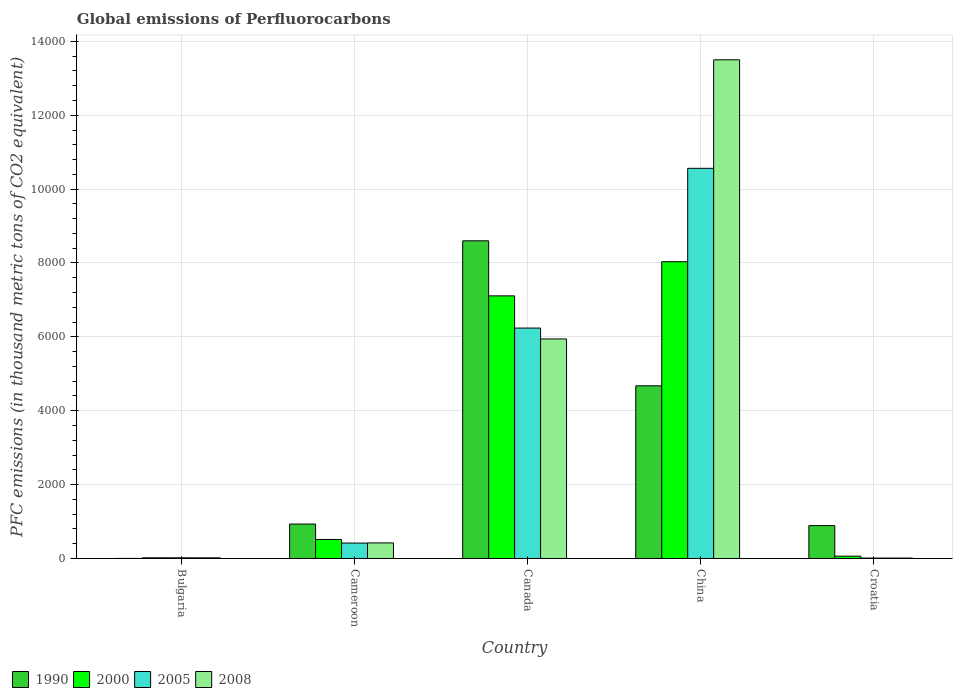How many different coloured bars are there?
Keep it short and to the point. 4. Are the number of bars per tick equal to the number of legend labels?
Your answer should be very brief. Yes. How many bars are there on the 1st tick from the left?
Make the answer very short. 4. How many bars are there on the 1st tick from the right?
Provide a short and direct response. 4. What is the label of the 1st group of bars from the left?
Offer a very short reply. Bulgaria. In how many cases, is the number of bars for a given country not equal to the number of legend labels?
Provide a short and direct response. 0. What is the global emissions of Perfluorocarbons in 1990 in Canada?
Make the answer very short. 8600.3. Across all countries, what is the maximum global emissions of Perfluorocarbons in 2000?
Your answer should be very brief. 8034.4. Across all countries, what is the minimum global emissions of Perfluorocarbons in 2008?
Give a very brief answer. 11. In which country was the global emissions of Perfluorocarbons in 1990 maximum?
Offer a very short reply. Canada. In which country was the global emissions of Perfluorocarbons in 2000 minimum?
Offer a terse response. Bulgaria. What is the total global emissions of Perfluorocarbons in 2000 in the graph?
Offer a terse response. 1.57e+04. What is the difference between the global emissions of Perfluorocarbons in 2008 in Bulgaria and that in Canada?
Your response must be concise. -5925.5. What is the difference between the global emissions of Perfluorocarbons in 2000 in Croatia and the global emissions of Perfluorocarbons in 2008 in Bulgaria?
Ensure brevity in your answer.  44.8. What is the average global emissions of Perfluorocarbons in 2005 per country?
Your answer should be compact. 3449.54. What is the difference between the global emissions of Perfluorocarbons of/in 1990 and global emissions of Perfluorocarbons of/in 2000 in Cameroon?
Keep it short and to the point. 417.6. In how many countries, is the global emissions of Perfluorocarbons in 2005 greater than 12800 thousand metric tons?
Your answer should be very brief. 0. What is the ratio of the global emissions of Perfluorocarbons in 2000 in Cameroon to that in Croatia?
Provide a short and direct response. 8.17. Is the global emissions of Perfluorocarbons in 2008 in Bulgaria less than that in Cameroon?
Keep it short and to the point. Yes. What is the difference between the highest and the second highest global emissions of Perfluorocarbons in 1990?
Keep it short and to the point. 3925.8. What is the difference between the highest and the lowest global emissions of Perfluorocarbons in 2000?
Your answer should be very brief. 8015.3. In how many countries, is the global emissions of Perfluorocarbons in 2005 greater than the average global emissions of Perfluorocarbons in 2005 taken over all countries?
Keep it short and to the point. 2. Is the sum of the global emissions of Perfluorocarbons in 1990 in Cameroon and Croatia greater than the maximum global emissions of Perfluorocarbons in 2008 across all countries?
Provide a short and direct response. No. Is it the case that in every country, the sum of the global emissions of Perfluorocarbons in 2005 and global emissions of Perfluorocarbons in 1990 is greater than the global emissions of Perfluorocarbons in 2008?
Make the answer very short. Yes. What is the difference between two consecutive major ticks on the Y-axis?
Keep it short and to the point. 2000. Are the values on the major ticks of Y-axis written in scientific E-notation?
Provide a succinct answer. No. Does the graph contain any zero values?
Ensure brevity in your answer.  No. How are the legend labels stacked?
Keep it short and to the point. Horizontal. What is the title of the graph?
Offer a terse response. Global emissions of Perfluorocarbons. Does "1979" appear as one of the legend labels in the graph?
Give a very brief answer. No. What is the label or title of the X-axis?
Provide a short and direct response. Country. What is the label or title of the Y-axis?
Give a very brief answer. PFC emissions (in thousand metric tons of CO2 equivalent). What is the PFC emissions (in thousand metric tons of CO2 equivalent) in 2000 in Bulgaria?
Provide a succinct answer. 19.1. What is the PFC emissions (in thousand metric tons of CO2 equivalent) of 2005 in Bulgaria?
Ensure brevity in your answer.  18.5. What is the PFC emissions (in thousand metric tons of CO2 equivalent) in 2008 in Bulgaria?
Give a very brief answer. 18.2. What is the PFC emissions (in thousand metric tons of CO2 equivalent) of 1990 in Cameroon?
Ensure brevity in your answer.  932.3. What is the PFC emissions (in thousand metric tons of CO2 equivalent) of 2000 in Cameroon?
Offer a very short reply. 514.7. What is the PFC emissions (in thousand metric tons of CO2 equivalent) in 2005 in Cameroon?
Keep it short and to the point. 417.5. What is the PFC emissions (in thousand metric tons of CO2 equivalent) in 2008 in Cameroon?
Your answer should be very brief. 422.1. What is the PFC emissions (in thousand metric tons of CO2 equivalent) in 1990 in Canada?
Provide a succinct answer. 8600.3. What is the PFC emissions (in thousand metric tons of CO2 equivalent) in 2000 in Canada?
Your answer should be very brief. 7109.9. What is the PFC emissions (in thousand metric tons of CO2 equivalent) of 2005 in Canada?
Offer a terse response. 6238. What is the PFC emissions (in thousand metric tons of CO2 equivalent) in 2008 in Canada?
Make the answer very short. 5943.7. What is the PFC emissions (in thousand metric tons of CO2 equivalent) of 1990 in China?
Provide a short and direct response. 4674.5. What is the PFC emissions (in thousand metric tons of CO2 equivalent) of 2000 in China?
Make the answer very short. 8034.4. What is the PFC emissions (in thousand metric tons of CO2 equivalent) of 2005 in China?
Offer a terse response. 1.06e+04. What is the PFC emissions (in thousand metric tons of CO2 equivalent) of 2008 in China?
Ensure brevity in your answer.  1.35e+04. What is the PFC emissions (in thousand metric tons of CO2 equivalent) in 1990 in Croatia?
Keep it short and to the point. 890.4. What is the PFC emissions (in thousand metric tons of CO2 equivalent) of 2005 in Croatia?
Provide a succinct answer. 10.9. Across all countries, what is the maximum PFC emissions (in thousand metric tons of CO2 equivalent) in 1990?
Give a very brief answer. 8600.3. Across all countries, what is the maximum PFC emissions (in thousand metric tons of CO2 equivalent) of 2000?
Your answer should be very brief. 8034.4. Across all countries, what is the maximum PFC emissions (in thousand metric tons of CO2 equivalent) of 2005?
Your response must be concise. 1.06e+04. Across all countries, what is the maximum PFC emissions (in thousand metric tons of CO2 equivalent) in 2008?
Offer a very short reply. 1.35e+04. Across all countries, what is the minimum PFC emissions (in thousand metric tons of CO2 equivalent) in 1990?
Your answer should be compact. 2.2. Across all countries, what is the minimum PFC emissions (in thousand metric tons of CO2 equivalent) in 2005?
Give a very brief answer. 10.9. Across all countries, what is the minimum PFC emissions (in thousand metric tons of CO2 equivalent) in 2008?
Your response must be concise. 11. What is the total PFC emissions (in thousand metric tons of CO2 equivalent) of 1990 in the graph?
Make the answer very short. 1.51e+04. What is the total PFC emissions (in thousand metric tons of CO2 equivalent) in 2000 in the graph?
Provide a succinct answer. 1.57e+04. What is the total PFC emissions (in thousand metric tons of CO2 equivalent) in 2005 in the graph?
Give a very brief answer. 1.72e+04. What is the total PFC emissions (in thousand metric tons of CO2 equivalent) in 2008 in the graph?
Make the answer very short. 1.99e+04. What is the difference between the PFC emissions (in thousand metric tons of CO2 equivalent) of 1990 in Bulgaria and that in Cameroon?
Give a very brief answer. -930.1. What is the difference between the PFC emissions (in thousand metric tons of CO2 equivalent) in 2000 in Bulgaria and that in Cameroon?
Keep it short and to the point. -495.6. What is the difference between the PFC emissions (in thousand metric tons of CO2 equivalent) of 2005 in Bulgaria and that in Cameroon?
Your answer should be very brief. -399. What is the difference between the PFC emissions (in thousand metric tons of CO2 equivalent) in 2008 in Bulgaria and that in Cameroon?
Your answer should be very brief. -403.9. What is the difference between the PFC emissions (in thousand metric tons of CO2 equivalent) in 1990 in Bulgaria and that in Canada?
Ensure brevity in your answer.  -8598.1. What is the difference between the PFC emissions (in thousand metric tons of CO2 equivalent) in 2000 in Bulgaria and that in Canada?
Offer a very short reply. -7090.8. What is the difference between the PFC emissions (in thousand metric tons of CO2 equivalent) in 2005 in Bulgaria and that in Canada?
Your answer should be compact. -6219.5. What is the difference between the PFC emissions (in thousand metric tons of CO2 equivalent) of 2008 in Bulgaria and that in Canada?
Provide a succinct answer. -5925.5. What is the difference between the PFC emissions (in thousand metric tons of CO2 equivalent) in 1990 in Bulgaria and that in China?
Your answer should be compact. -4672.3. What is the difference between the PFC emissions (in thousand metric tons of CO2 equivalent) in 2000 in Bulgaria and that in China?
Offer a very short reply. -8015.3. What is the difference between the PFC emissions (in thousand metric tons of CO2 equivalent) in 2005 in Bulgaria and that in China?
Give a very brief answer. -1.05e+04. What is the difference between the PFC emissions (in thousand metric tons of CO2 equivalent) in 2008 in Bulgaria and that in China?
Keep it short and to the point. -1.35e+04. What is the difference between the PFC emissions (in thousand metric tons of CO2 equivalent) of 1990 in Bulgaria and that in Croatia?
Offer a terse response. -888.2. What is the difference between the PFC emissions (in thousand metric tons of CO2 equivalent) of 2000 in Bulgaria and that in Croatia?
Ensure brevity in your answer.  -43.9. What is the difference between the PFC emissions (in thousand metric tons of CO2 equivalent) in 2005 in Bulgaria and that in Croatia?
Keep it short and to the point. 7.6. What is the difference between the PFC emissions (in thousand metric tons of CO2 equivalent) of 1990 in Cameroon and that in Canada?
Your answer should be very brief. -7668. What is the difference between the PFC emissions (in thousand metric tons of CO2 equivalent) in 2000 in Cameroon and that in Canada?
Offer a very short reply. -6595.2. What is the difference between the PFC emissions (in thousand metric tons of CO2 equivalent) of 2005 in Cameroon and that in Canada?
Offer a very short reply. -5820.5. What is the difference between the PFC emissions (in thousand metric tons of CO2 equivalent) in 2008 in Cameroon and that in Canada?
Keep it short and to the point. -5521.6. What is the difference between the PFC emissions (in thousand metric tons of CO2 equivalent) in 1990 in Cameroon and that in China?
Keep it short and to the point. -3742.2. What is the difference between the PFC emissions (in thousand metric tons of CO2 equivalent) in 2000 in Cameroon and that in China?
Provide a succinct answer. -7519.7. What is the difference between the PFC emissions (in thousand metric tons of CO2 equivalent) in 2005 in Cameroon and that in China?
Provide a succinct answer. -1.01e+04. What is the difference between the PFC emissions (in thousand metric tons of CO2 equivalent) in 2008 in Cameroon and that in China?
Make the answer very short. -1.31e+04. What is the difference between the PFC emissions (in thousand metric tons of CO2 equivalent) of 1990 in Cameroon and that in Croatia?
Make the answer very short. 41.9. What is the difference between the PFC emissions (in thousand metric tons of CO2 equivalent) in 2000 in Cameroon and that in Croatia?
Keep it short and to the point. 451.7. What is the difference between the PFC emissions (in thousand metric tons of CO2 equivalent) in 2005 in Cameroon and that in Croatia?
Your answer should be compact. 406.6. What is the difference between the PFC emissions (in thousand metric tons of CO2 equivalent) of 2008 in Cameroon and that in Croatia?
Provide a short and direct response. 411.1. What is the difference between the PFC emissions (in thousand metric tons of CO2 equivalent) in 1990 in Canada and that in China?
Ensure brevity in your answer.  3925.8. What is the difference between the PFC emissions (in thousand metric tons of CO2 equivalent) in 2000 in Canada and that in China?
Offer a terse response. -924.5. What is the difference between the PFC emissions (in thousand metric tons of CO2 equivalent) in 2005 in Canada and that in China?
Your answer should be compact. -4324.8. What is the difference between the PFC emissions (in thousand metric tons of CO2 equivalent) in 2008 in Canada and that in China?
Provide a succinct answer. -7556.9. What is the difference between the PFC emissions (in thousand metric tons of CO2 equivalent) of 1990 in Canada and that in Croatia?
Give a very brief answer. 7709.9. What is the difference between the PFC emissions (in thousand metric tons of CO2 equivalent) of 2000 in Canada and that in Croatia?
Keep it short and to the point. 7046.9. What is the difference between the PFC emissions (in thousand metric tons of CO2 equivalent) of 2005 in Canada and that in Croatia?
Make the answer very short. 6227.1. What is the difference between the PFC emissions (in thousand metric tons of CO2 equivalent) in 2008 in Canada and that in Croatia?
Make the answer very short. 5932.7. What is the difference between the PFC emissions (in thousand metric tons of CO2 equivalent) in 1990 in China and that in Croatia?
Provide a short and direct response. 3784.1. What is the difference between the PFC emissions (in thousand metric tons of CO2 equivalent) of 2000 in China and that in Croatia?
Provide a short and direct response. 7971.4. What is the difference between the PFC emissions (in thousand metric tons of CO2 equivalent) in 2005 in China and that in Croatia?
Offer a terse response. 1.06e+04. What is the difference between the PFC emissions (in thousand metric tons of CO2 equivalent) of 2008 in China and that in Croatia?
Provide a succinct answer. 1.35e+04. What is the difference between the PFC emissions (in thousand metric tons of CO2 equivalent) in 1990 in Bulgaria and the PFC emissions (in thousand metric tons of CO2 equivalent) in 2000 in Cameroon?
Your answer should be very brief. -512.5. What is the difference between the PFC emissions (in thousand metric tons of CO2 equivalent) of 1990 in Bulgaria and the PFC emissions (in thousand metric tons of CO2 equivalent) of 2005 in Cameroon?
Your answer should be compact. -415.3. What is the difference between the PFC emissions (in thousand metric tons of CO2 equivalent) of 1990 in Bulgaria and the PFC emissions (in thousand metric tons of CO2 equivalent) of 2008 in Cameroon?
Make the answer very short. -419.9. What is the difference between the PFC emissions (in thousand metric tons of CO2 equivalent) of 2000 in Bulgaria and the PFC emissions (in thousand metric tons of CO2 equivalent) of 2005 in Cameroon?
Provide a succinct answer. -398.4. What is the difference between the PFC emissions (in thousand metric tons of CO2 equivalent) of 2000 in Bulgaria and the PFC emissions (in thousand metric tons of CO2 equivalent) of 2008 in Cameroon?
Offer a terse response. -403. What is the difference between the PFC emissions (in thousand metric tons of CO2 equivalent) in 2005 in Bulgaria and the PFC emissions (in thousand metric tons of CO2 equivalent) in 2008 in Cameroon?
Ensure brevity in your answer.  -403.6. What is the difference between the PFC emissions (in thousand metric tons of CO2 equivalent) of 1990 in Bulgaria and the PFC emissions (in thousand metric tons of CO2 equivalent) of 2000 in Canada?
Offer a terse response. -7107.7. What is the difference between the PFC emissions (in thousand metric tons of CO2 equivalent) in 1990 in Bulgaria and the PFC emissions (in thousand metric tons of CO2 equivalent) in 2005 in Canada?
Ensure brevity in your answer.  -6235.8. What is the difference between the PFC emissions (in thousand metric tons of CO2 equivalent) in 1990 in Bulgaria and the PFC emissions (in thousand metric tons of CO2 equivalent) in 2008 in Canada?
Provide a short and direct response. -5941.5. What is the difference between the PFC emissions (in thousand metric tons of CO2 equivalent) of 2000 in Bulgaria and the PFC emissions (in thousand metric tons of CO2 equivalent) of 2005 in Canada?
Provide a succinct answer. -6218.9. What is the difference between the PFC emissions (in thousand metric tons of CO2 equivalent) in 2000 in Bulgaria and the PFC emissions (in thousand metric tons of CO2 equivalent) in 2008 in Canada?
Ensure brevity in your answer.  -5924.6. What is the difference between the PFC emissions (in thousand metric tons of CO2 equivalent) in 2005 in Bulgaria and the PFC emissions (in thousand metric tons of CO2 equivalent) in 2008 in Canada?
Offer a terse response. -5925.2. What is the difference between the PFC emissions (in thousand metric tons of CO2 equivalent) in 1990 in Bulgaria and the PFC emissions (in thousand metric tons of CO2 equivalent) in 2000 in China?
Make the answer very short. -8032.2. What is the difference between the PFC emissions (in thousand metric tons of CO2 equivalent) in 1990 in Bulgaria and the PFC emissions (in thousand metric tons of CO2 equivalent) in 2005 in China?
Your response must be concise. -1.06e+04. What is the difference between the PFC emissions (in thousand metric tons of CO2 equivalent) in 1990 in Bulgaria and the PFC emissions (in thousand metric tons of CO2 equivalent) in 2008 in China?
Offer a very short reply. -1.35e+04. What is the difference between the PFC emissions (in thousand metric tons of CO2 equivalent) of 2000 in Bulgaria and the PFC emissions (in thousand metric tons of CO2 equivalent) of 2005 in China?
Provide a short and direct response. -1.05e+04. What is the difference between the PFC emissions (in thousand metric tons of CO2 equivalent) of 2000 in Bulgaria and the PFC emissions (in thousand metric tons of CO2 equivalent) of 2008 in China?
Provide a succinct answer. -1.35e+04. What is the difference between the PFC emissions (in thousand metric tons of CO2 equivalent) of 2005 in Bulgaria and the PFC emissions (in thousand metric tons of CO2 equivalent) of 2008 in China?
Provide a succinct answer. -1.35e+04. What is the difference between the PFC emissions (in thousand metric tons of CO2 equivalent) of 1990 in Bulgaria and the PFC emissions (in thousand metric tons of CO2 equivalent) of 2000 in Croatia?
Keep it short and to the point. -60.8. What is the difference between the PFC emissions (in thousand metric tons of CO2 equivalent) of 1990 in Bulgaria and the PFC emissions (in thousand metric tons of CO2 equivalent) of 2005 in Croatia?
Keep it short and to the point. -8.7. What is the difference between the PFC emissions (in thousand metric tons of CO2 equivalent) in 1990 in Bulgaria and the PFC emissions (in thousand metric tons of CO2 equivalent) in 2008 in Croatia?
Your answer should be very brief. -8.8. What is the difference between the PFC emissions (in thousand metric tons of CO2 equivalent) of 2000 in Bulgaria and the PFC emissions (in thousand metric tons of CO2 equivalent) of 2005 in Croatia?
Provide a short and direct response. 8.2. What is the difference between the PFC emissions (in thousand metric tons of CO2 equivalent) in 2005 in Bulgaria and the PFC emissions (in thousand metric tons of CO2 equivalent) in 2008 in Croatia?
Give a very brief answer. 7.5. What is the difference between the PFC emissions (in thousand metric tons of CO2 equivalent) of 1990 in Cameroon and the PFC emissions (in thousand metric tons of CO2 equivalent) of 2000 in Canada?
Provide a succinct answer. -6177.6. What is the difference between the PFC emissions (in thousand metric tons of CO2 equivalent) in 1990 in Cameroon and the PFC emissions (in thousand metric tons of CO2 equivalent) in 2005 in Canada?
Keep it short and to the point. -5305.7. What is the difference between the PFC emissions (in thousand metric tons of CO2 equivalent) of 1990 in Cameroon and the PFC emissions (in thousand metric tons of CO2 equivalent) of 2008 in Canada?
Offer a very short reply. -5011.4. What is the difference between the PFC emissions (in thousand metric tons of CO2 equivalent) in 2000 in Cameroon and the PFC emissions (in thousand metric tons of CO2 equivalent) in 2005 in Canada?
Your answer should be very brief. -5723.3. What is the difference between the PFC emissions (in thousand metric tons of CO2 equivalent) in 2000 in Cameroon and the PFC emissions (in thousand metric tons of CO2 equivalent) in 2008 in Canada?
Provide a succinct answer. -5429. What is the difference between the PFC emissions (in thousand metric tons of CO2 equivalent) of 2005 in Cameroon and the PFC emissions (in thousand metric tons of CO2 equivalent) of 2008 in Canada?
Offer a very short reply. -5526.2. What is the difference between the PFC emissions (in thousand metric tons of CO2 equivalent) of 1990 in Cameroon and the PFC emissions (in thousand metric tons of CO2 equivalent) of 2000 in China?
Your answer should be very brief. -7102.1. What is the difference between the PFC emissions (in thousand metric tons of CO2 equivalent) in 1990 in Cameroon and the PFC emissions (in thousand metric tons of CO2 equivalent) in 2005 in China?
Provide a succinct answer. -9630.5. What is the difference between the PFC emissions (in thousand metric tons of CO2 equivalent) in 1990 in Cameroon and the PFC emissions (in thousand metric tons of CO2 equivalent) in 2008 in China?
Ensure brevity in your answer.  -1.26e+04. What is the difference between the PFC emissions (in thousand metric tons of CO2 equivalent) in 2000 in Cameroon and the PFC emissions (in thousand metric tons of CO2 equivalent) in 2005 in China?
Offer a terse response. -1.00e+04. What is the difference between the PFC emissions (in thousand metric tons of CO2 equivalent) in 2000 in Cameroon and the PFC emissions (in thousand metric tons of CO2 equivalent) in 2008 in China?
Offer a very short reply. -1.30e+04. What is the difference between the PFC emissions (in thousand metric tons of CO2 equivalent) in 2005 in Cameroon and the PFC emissions (in thousand metric tons of CO2 equivalent) in 2008 in China?
Offer a terse response. -1.31e+04. What is the difference between the PFC emissions (in thousand metric tons of CO2 equivalent) of 1990 in Cameroon and the PFC emissions (in thousand metric tons of CO2 equivalent) of 2000 in Croatia?
Ensure brevity in your answer.  869.3. What is the difference between the PFC emissions (in thousand metric tons of CO2 equivalent) of 1990 in Cameroon and the PFC emissions (in thousand metric tons of CO2 equivalent) of 2005 in Croatia?
Your response must be concise. 921.4. What is the difference between the PFC emissions (in thousand metric tons of CO2 equivalent) in 1990 in Cameroon and the PFC emissions (in thousand metric tons of CO2 equivalent) in 2008 in Croatia?
Your answer should be compact. 921.3. What is the difference between the PFC emissions (in thousand metric tons of CO2 equivalent) in 2000 in Cameroon and the PFC emissions (in thousand metric tons of CO2 equivalent) in 2005 in Croatia?
Your response must be concise. 503.8. What is the difference between the PFC emissions (in thousand metric tons of CO2 equivalent) of 2000 in Cameroon and the PFC emissions (in thousand metric tons of CO2 equivalent) of 2008 in Croatia?
Provide a succinct answer. 503.7. What is the difference between the PFC emissions (in thousand metric tons of CO2 equivalent) in 2005 in Cameroon and the PFC emissions (in thousand metric tons of CO2 equivalent) in 2008 in Croatia?
Ensure brevity in your answer.  406.5. What is the difference between the PFC emissions (in thousand metric tons of CO2 equivalent) of 1990 in Canada and the PFC emissions (in thousand metric tons of CO2 equivalent) of 2000 in China?
Offer a very short reply. 565.9. What is the difference between the PFC emissions (in thousand metric tons of CO2 equivalent) of 1990 in Canada and the PFC emissions (in thousand metric tons of CO2 equivalent) of 2005 in China?
Offer a very short reply. -1962.5. What is the difference between the PFC emissions (in thousand metric tons of CO2 equivalent) of 1990 in Canada and the PFC emissions (in thousand metric tons of CO2 equivalent) of 2008 in China?
Your answer should be very brief. -4900.3. What is the difference between the PFC emissions (in thousand metric tons of CO2 equivalent) in 2000 in Canada and the PFC emissions (in thousand metric tons of CO2 equivalent) in 2005 in China?
Make the answer very short. -3452.9. What is the difference between the PFC emissions (in thousand metric tons of CO2 equivalent) of 2000 in Canada and the PFC emissions (in thousand metric tons of CO2 equivalent) of 2008 in China?
Give a very brief answer. -6390.7. What is the difference between the PFC emissions (in thousand metric tons of CO2 equivalent) in 2005 in Canada and the PFC emissions (in thousand metric tons of CO2 equivalent) in 2008 in China?
Your answer should be compact. -7262.6. What is the difference between the PFC emissions (in thousand metric tons of CO2 equivalent) of 1990 in Canada and the PFC emissions (in thousand metric tons of CO2 equivalent) of 2000 in Croatia?
Provide a succinct answer. 8537.3. What is the difference between the PFC emissions (in thousand metric tons of CO2 equivalent) in 1990 in Canada and the PFC emissions (in thousand metric tons of CO2 equivalent) in 2005 in Croatia?
Provide a short and direct response. 8589.4. What is the difference between the PFC emissions (in thousand metric tons of CO2 equivalent) in 1990 in Canada and the PFC emissions (in thousand metric tons of CO2 equivalent) in 2008 in Croatia?
Offer a very short reply. 8589.3. What is the difference between the PFC emissions (in thousand metric tons of CO2 equivalent) of 2000 in Canada and the PFC emissions (in thousand metric tons of CO2 equivalent) of 2005 in Croatia?
Offer a terse response. 7099. What is the difference between the PFC emissions (in thousand metric tons of CO2 equivalent) of 2000 in Canada and the PFC emissions (in thousand metric tons of CO2 equivalent) of 2008 in Croatia?
Provide a short and direct response. 7098.9. What is the difference between the PFC emissions (in thousand metric tons of CO2 equivalent) in 2005 in Canada and the PFC emissions (in thousand metric tons of CO2 equivalent) in 2008 in Croatia?
Offer a terse response. 6227. What is the difference between the PFC emissions (in thousand metric tons of CO2 equivalent) of 1990 in China and the PFC emissions (in thousand metric tons of CO2 equivalent) of 2000 in Croatia?
Your answer should be very brief. 4611.5. What is the difference between the PFC emissions (in thousand metric tons of CO2 equivalent) of 1990 in China and the PFC emissions (in thousand metric tons of CO2 equivalent) of 2005 in Croatia?
Your answer should be very brief. 4663.6. What is the difference between the PFC emissions (in thousand metric tons of CO2 equivalent) of 1990 in China and the PFC emissions (in thousand metric tons of CO2 equivalent) of 2008 in Croatia?
Your answer should be compact. 4663.5. What is the difference between the PFC emissions (in thousand metric tons of CO2 equivalent) in 2000 in China and the PFC emissions (in thousand metric tons of CO2 equivalent) in 2005 in Croatia?
Provide a succinct answer. 8023.5. What is the difference between the PFC emissions (in thousand metric tons of CO2 equivalent) in 2000 in China and the PFC emissions (in thousand metric tons of CO2 equivalent) in 2008 in Croatia?
Give a very brief answer. 8023.4. What is the difference between the PFC emissions (in thousand metric tons of CO2 equivalent) of 2005 in China and the PFC emissions (in thousand metric tons of CO2 equivalent) of 2008 in Croatia?
Your answer should be very brief. 1.06e+04. What is the average PFC emissions (in thousand metric tons of CO2 equivalent) of 1990 per country?
Provide a short and direct response. 3019.94. What is the average PFC emissions (in thousand metric tons of CO2 equivalent) in 2000 per country?
Make the answer very short. 3148.22. What is the average PFC emissions (in thousand metric tons of CO2 equivalent) of 2005 per country?
Your response must be concise. 3449.54. What is the average PFC emissions (in thousand metric tons of CO2 equivalent) in 2008 per country?
Provide a succinct answer. 3979.12. What is the difference between the PFC emissions (in thousand metric tons of CO2 equivalent) in 1990 and PFC emissions (in thousand metric tons of CO2 equivalent) in 2000 in Bulgaria?
Offer a very short reply. -16.9. What is the difference between the PFC emissions (in thousand metric tons of CO2 equivalent) in 1990 and PFC emissions (in thousand metric tons of CO2 equivalent) in 2005 in Bulgaria?
Offer a terse response. -16.3. What is the difference between the PFC emissions (in thousand metric tons of CO2 equivalent) of 2005 and PFC emissions (in thousand metric tons of CO2 equivalent) of 2008 in Bulgaria?
Give a very brief answer. 0.3. What is the difference between the PFC emissions (in thousand metric tons of CO2 equivalent) of 1990 and PFC emissions (in thousand metric tons of CO2 equivalent) of 2000 in Cameroon?
Your answer should be very brief. 417.6. What is the difference between the PFC emissions (in thousand metric tons of CO2 equivalent) of 1990 and PFC emissions (in thousand metric tons of CO2 equivalent) of 2005 in Cameroon?
Provide a short and direct response. 514.8. What is the difference between the PFC emissions (in thousand metric tons of CO2 equivalent) in 1990 and PFC emissions (in thousand metric tons of CO2 equivalent) in 2008 in Cameroon?
Give a very brief answer. 510.2. What is the difference between the PFC emissions (in thousand metric tons of CO2 equivalent) of 2000 and PFC emissions (in thousand metric tons of CO2 equivalent) of 2005 in Cameroon?
Ensure brevity in your answer.  97.2. What is the difference between the PFC emissions (in thousand metric tons of CO2 equivalent) in 2000 and PFC emissions (in thousand metric tons of CO2 equivalent) in 2008 in Cameroon?
Your answer should be compact. 92.6. What is the difference between the PFC emissions (in thousand metric tons of CO2 equivalent) of 2005 and PFC emissions (in thousand metric tons of CO2 equivalent) of 2008 in Cameroon?
Your answer should be very brief. -4.6. What is the difference between the PFC emissions (in thousand metric tons of CO2 equivalent) in 1990 and PFC emissions (in thousand metric tons of CO2 equivalent) in 2000 in Canada?
Offer a very short reply. 1490.4. What is the difference between the PFC emissions (in thousand metric tons of CO2 equivalent) of 1990 and PFC emissions (in thousand metric tons of CO2 equivalent) of 2005 in Canada?
Provide a short and direct response. 2362.3. What is the difference between the PFC emissions (in thousand metric tons of CO2 equivalent) in 1990 and PFC emissions (in thousand metric tons of CO2 equivalent) in 2008 in Canada?
Make the answer very short. 2656.6. What is the difference between the PFC emissions (in thousand metric tons of CO2 equivalent) in 2000 and PFC emissions (in thousand metric tons of CO2 equivalent) in 2005 in Canada?
Offer a terse response. 871.9. What is the difference between the PFC emissions (in thousand metric tons of CO2 equivalent) of 2000 and PFC emissions (in thousand metric tons of CO2 equivalent) of 2008 in Canada?
Provide a short and direct response. 1166.2. What is the difference between the PFC emissions (in thousand metric tons of CO2 equivalent) of 2005 and PFC emissions (in thousand metric tons of CO2 equivalent) of 2008 in Canada?
Ensure brevity in your answer.  294.3. What is the difference between the PFC emissions (in thousand metric tons of CO2 equivalent) of 1990 and PFC emissions (in thousand metric tons of CO2 equivalent) of 2000 in China?
Give a very brief answer. -3359.9. What is the difference between the PFC emissions (in thousand metric tons of CO2 equivalent) of 1990 and PFC emissions (in thousand metric tons of CO2 equivalent) of 2005 in China?
Your answer should be compact. -5888.3. What is the difference between the PFC emissions (in thousand metric tons of CO2 equivalent) of 1990 and PFC emissions (in thousand metric tons of CO2 equivalent) of 2008 in China?
Make the answer very short. -8826.1. What is the difference between the PFC emissions (in thousand metric tons of CO2 equivalent) of 2000 and PFC emissions (in thousand metric tons of CO2 equivalent) of 2005 in China?
Make the answer very short. -2528.4. What is the difference between the PFC emissions (in thousand metric tons of CO2 equivalent) in 2000 and PFC emissions (in thousand metric tons of CO2 equivalent) in 2008 in China?
Your answer should be compact. -5466.2. What is the difference between the PFC emissions (in thousand metric tons of CO2 equivalent) of 2005 and PFC emissions (in thousand metric tons of CO2 equivalent) of 2008 in China?
Keep it short and to the point. -2937.8. What is the difference between the PFC emissions (in thousand metric tons of CO2 equivalent) in 1990 and PFC emissions (in thousand metric tons of CO2 equivalent) in 2000 in Croatia?
Your answer should be compact. 827.4. What is the difference between the PFC emissions (in thousand metric tons of CO2 equivalent) in 1990 and PFC emissions (in thousand metric tons of CO2 equivalent) in 2005 in Croatia?
Ensure brevity in your answer.  879.5. What is the difference between the PFC emissions (in thousand metric tons of CO2 equivalent) in 1990 and PFC emissions (in thousand metric tons of CO2 equivalent) in 2008 in Croatia?
Give a very brief answer. 879.4. What is the difference between the PFC emissions (in thousand metric tons of CO2 equivalent) in 2000 and PFC emissions (in thousand metric tons of CO2 equivalent) in 2005 in Croatia?
Give a very brief answer. 52.1. What is the difference between the PFC emissions (in thousand metric tons of CO2 equivalent) in 2000 and PFC emissions (in thousand metric tons of CO2 equivalent) in 2008 in Croatia?
Offer a very short reply. 52. What is the ratio of the PFC emissions (in thousand metric tons of CO2 equivalent) in 1990 in Bulgaria to that in Cameroon?
Your response must be concise. 0. What is the ratio of the PFC emissions (in thousand metric tons of CO2 equivalent) of 2000 in Bulgaria to that in Cameroon?
Your answer should be compact. 0.04. What is the ratio of the PFC emissions (in thousand metric tons of CO2 equivalent) in 2005 in Bulgaria to that in Cameroon?
Ensure brevity in your answer.  0.04. What is the ratio of the PFC emissions (in thousand metric tons of CO2 equivalent) in 2008 in Bulgaria to that in Cameroon?
Your answer should be compact. 0.04. What is the ratio of the PFC emissions (in thousand metric tons of CO2 equivalent) in 2000 in Bulgaria to that in Canada?
Give a very brief answer. 0. What is the ratio of the PFC emissions (in thousand metric tons of CO2 equivalent) of 2005 in Bulgaria to that in Canada?
Make the answer very short. 0. What is the ratio of the PFC emissions (in thousand metric tons of CO2 equivalent) of 2008 in Bulgaria to that in Canada?
Your answer should be very brief. 0. What is the ratio of the PFC emissions (in thousand metric tons of CO2 equivalent) in 1990 in Bulgaria to that in China?
Make the answer very short. 0. What is the ratio of the PFC emissions (in thousand metric tons of CO2 equivalent) of 2000 in Bulgaria to that in China?
Keep it short and to the point. 0. What is the ratio of the PFC emissions (in thousand metric tons of CO2 equivalent) of 2005 in Bulgaria to that in China?
Make the answer very short. 0. What is the ratio of the PFC emissions (in thousand metric tons of CO2 equivalent) in 2008 in Bulgaria to that in China?
Give a very brief answer. 0. What is the ratio of the PFC emissions (in thousand metric tons of CO2 equivalent) in 1990 in Bulgaria to that in Croatia?
Provide a short and direct response. 0. What is the ratio of the PFC emissions (in thousand metric tons of CO2 equivalent) in 2000 in Bulgaria to that in Croatia?
Your response must be concise. 0.3. What is the ratio of the PFC emissions (in thousand metric tons of CO2 equivalent) of 2005 in Bulgaria to that in Croatia?
Keep it short and to the point. 1.7. What is the ratio of the PFC emissions (in thousand metric tons of CO2 equivalent) of 2008 in Bulgaria to that in Croatia?
Make the answer very short. 1.65. What is the ratio of the PFC emissions (in thousand metric tons of CO2 equivalent) in 1990 in Cameroon to that in Canada?
Your answer should be compact. 0.11. What is the ratio of the PFC emissions (in thousand metric tons of CO2 equivalent) of 2000 in Cameroon to that in Canada?
Make the answer very short. 0.07. What is the ratio of the PFC emissions (in thousand metric tons of CO2 equivalent) in 2005 in Cameroon to that in Canada?
Provide a short and direct response. 0.07. What is the ratio of the PFC emissions (in thousand metric tons of CO2 equivalent) in 2008 in Cameroon to that in Canada?
Offer a terse response. 0.07. What is the ratio of the PFC emissions (in thousand metric tons of CO2 equivalent) in 1990 in Cameroon to that in China?
Your answer should be very brief. 0.2. What is the ratio of the PFC emissions (in thousand metric tons of CO2 equivalent) of 2000 in Cameroon to that in China?
Make the answer very short. 0.06. What is the ratio of the PFC emissions (in thousand metric tons of CO2 equivalent) of 2005 in Cameroon to that in China?
Your response must be concise. 0.04. What is the ratio of the PFC emissions (in thousand metric tons of CO2 equivalent) in 2008 in Cameroon to that in China?
Provide a succinct answer. 0.03. What is the ratio of the PFC emissions (in thousand metric tons of CO2 equivalent) of 1990 in Cameroon to that in Croatia?
Ensure brevity in your answer.  1.05. What is the ratio of the PFC emissions (in thousand metric tons of CO2 equivalent) of 2000 in Cameroon to that in Croatia?
Give a very brief answer. 8.17. What is the ratio of the PFC emissions (in thousand metric tons of CO2 equivalent) of 2005 in Cameroon to that in Croatia?
Your answer should be very brief. 38.3. What is the ratio of the PFC emissions (in thousand metric tons of CO2 equivalent) in 2008 in Cameroon to that in Croatia?
Provide a short and direct response. 38.37. What is the ratio of the PFC emissions (in thousand metric tons of CO2 equivalent) in 1990 in Canada to that in China?
Make the answer very short. 1.84. What is the ratio of the PFC emissions (in thousand metric tons of CO2 equivalent) of 2000 in Canada to that in China?
Keep it short and to the point. 0.88. What is the ratio of the PFC emissions (in thousand metric tons of CO2 equivalent) in 2005 in Canada to that in China?
Ensure brevity in your answer.  0.59. What is the ratio of the PFC emissions (in thousand metric tons of CO2 equivalent) of 2008 in Canada to that in China?
Give a very brief answer. 0.44. What is the ratio of the PFC emissions (in thousand metric tons of CO2 equivalent) in 1990 in Canada to that in Croatia?
Ensure brevity in your answer.  9.66. What is the ratio of the PFC emissions (in thousand metric tons of CO2 equivalent) in 2000 in Canada to that in Croatia?
Your response must be concise. 112.86. What is the ratio of the PFC emissions (in thousand metric tons of CO2 equivalent) of 2005 in Canada to that in Croatia?
Ensure brevity in your answer.  572.29. What is the ratio of the PFC emissions (in thousand metric tons of CO2 equivalent) in 2008 in Canada to that in Croatia?
Make the answer very short. 540.34. What is the ratio of the PFC emissions (in thousand metric tons of CO2 equivalent) in 1990 in China to that in Croatia?
Provide a succinct answer. 5.25. What is the ratio of the PFC emissions (in thousand metric tons of CO2 equivalent) of 2000 in China to that in Croatia?
Provide a short and direct response. 127.53. What is the ratio of the PFC emissions (in thousand metric tons of CO2 equivalent) of 2005 in China to that in Croatia?
Keep it short and to the point. 969.06. What is the ratio of the PFC emissions (in thousand metric tons of CO2 equivalent) in 2008 in China to that in Croatia?
Give a very brief answer. 1227.33. What is the difference between the highest and the second highest PFC emissions (in thousand metric tons of CO2 equivalent) in 1990?
Your response must be concise. 3925.8. What is the difference between the highest and the second highest PFC emissions (in thousand metric tons of CO2 equivalent) in 2000?
Your response must be concise. 924.5. What is the difference between the highest and the second highest PFC emissions (in thousand metric tons of CO2 equivalent) in 2005?
Offer a very short reply. 4324.8. What is the difference between the highest and the second highest PFC emissions (in thousand metric tons of CO2 equivalent) of 2008?
Make the answer very short. 7556.9. What is the difference between the highest and the lowest PFC emissions (in thousand metric tons of CO2 equivalent) in 1990?
Offer a terse response. 8598.1. What is the difference between the highest and the lowest PFC emissions (in thousand metric tons of CO2 equivalent) of 2000?
Your answer should be very brief. 8015.3. What is the difference between the highest and the lowest PFC emissions (in thousand metric tons of CO2 equivalent) of 2005?
Make the answer very short. 1.06e+04. What is the difference between the highest and the lowest PFC emissions (in thousand metric tons of CO2 equivalent) in 2008?
Your response must be concise. 1.35e+04. 